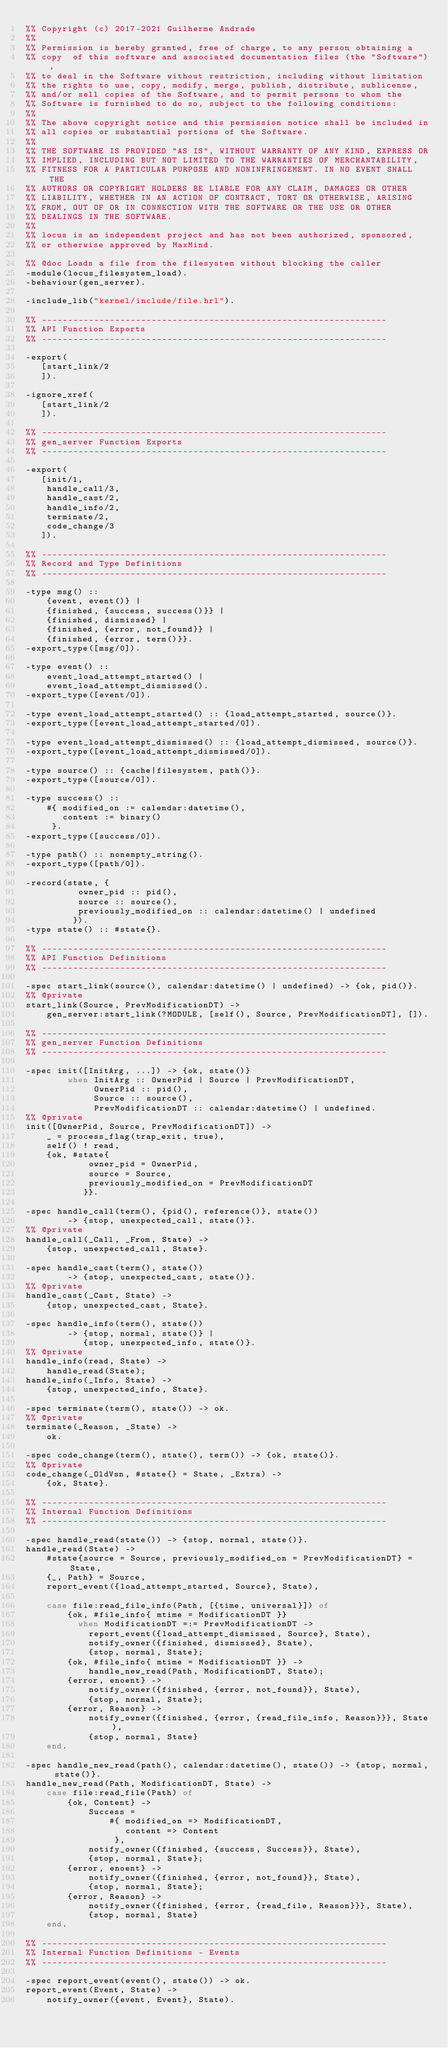Convert code to text. <code><loc_0><loc_0><loc_500><loc_500><_Erlang_>%% Copyright (c) 2017-2021 Guilherme Andrade
%%
%% Permission is hereby granted, free of charge, to any person obtaining a
%% copy  of this software and associated documentation files (the "Software"),
%% to deal in the Software without restriction, including without limitation
%% the rights to use, copy, modify, merge, publish, distribute, sublicense,
%% and/or sell copies of the Software, and to permit persons to whom the
%% Software is furnished to do so, subject to the following conditions:
%%
%% The above copyright notice and this permission notice shall be included in
%% all copies or substantial portions of the Software.
%%
%% THE SOFTWARE IS PROVIDED "AS IS", WITHOUT WARRANTY OF ANY KIND, EXPRESS OR
%% IMPLIED, INCLUDING BUT NOT LIMITED TO THE WARRANTIES OF MERCHANTABILITY,
%% FITNESS FOR A PARTICULAR PURPOSE AND NONINFRINGEMENT. IN NO EVENT SHALL THE
%% AUTHORS OR COPYRIGHT HOLDERS BE LIABLE FOR ANY CLAIM, DAMAGES OR OTHER
%% LIABILITY, WHETHER IN AN ACTION OF CONTRACT, TORT OR OTHERWISE, ARISING
%% FROM, OUT OF OR IN CONNECTION WITH THE SOFTWARE OR THE USE OR OTHER
%% DEALINGS IN THE SOFTWARE.
%%
%% locus is an independent project and has not been authorized, sponsored,
%% or otherwise approved by MaxMind.

%% @doc Loads a file from the filesystem without blocking the caller
-module(locus_filesystem_load).
-behaviour(gen_server).

-include_lib("kernel/include/file.hrl").

%% ------------------------------------------------------------------
%% API Function Exports
%% ------------------------------------------------------------------

-export(
   [start_link/2
   ]).

-ignore_xref(
   [start_link/2
   ]).

%% ------------------------------------------------------------------
%% gen_server Function Exports
%% ------------------------------------------------------------------

-export(
   [init/1,
    handle_call/3,
    handle_cast/2,
    handle_info/2,
    terminate/2,
    code_change/3
   ]).

%% ------------------------------------------------------------------
%% Record and Type Definitions
%% ------------------------------------------------------------------

-type msg() ::
    {event, event()} |
    {finished, {success, success()}} |
    {finished, dismissed} |
    {finished, {error, not_found}} |
    {finished, {error, term()}}.
-export_type([msg/0]).

-type event() ::
    event_load_attempt_started() |
    event_load_attempt_dismissed().
-export_type([event/0]).

-type event_load_attempt_started() :: {load_attempt_started, source()}.
-export_type([event_load_attempt_started/0]).

-type event_load_attempt_dismissed() :: {load_attempt_dismissed, source()}.
-export_type([event_load_attempt_dismissed/0]).

-type source() :: {cache|filesystem, path()}.
-export_type([source/0]).

-type success() ::
    #{ modified_on := calendar:datetime(),
       content := binary()
     }.
-export_type([success/0]).

-type path() :: nonempty_string().
-export_type([path/0]).

-record(state, {
          owner_pid :: pid(),
          source :: source(),
          previously_modified_on :: calendar:datetime() | undefined
         }).
-type state() :: #state{}.

%% ------------------------------------------------------------------
%% API Function Definitions
%% ------------------------------------------------------------------

-spec start_link(source(), calendar:datetime() | undefined) -> {ok, pid()}.
%% @private
start_link(Source, PrevModificationDT) ->
    gen_server:start_link(?MODULE, [self(), Source, PrevModificationDT], []).

%% ------------------------------------------------------------------
%% gen_server Function Definitions
%% ------------------------------------------------------------------

-spec init([InitArg, ...]) -> {ok, state()}
        when InitArg :: OwnerPid | Source | PrevModificationDT,
             OwnerPid :: pid(),
             Source :: source(),
             PrevModificationDT :: calendar:datetime() | undefined.
%% @private
init([OwnerPid, Source, PrevModificationDT]) ->
    _ = process_flag(trap_exit, true),
    self() ! read,
    {ok, #state{
            owner_pid = OwnerPid,
            source = Source,
            previously_modified_on = PrevModificationDT
           }}.

-spec handle_call(term(), {pid(), reference()}, state())
        -> {stop, unexpected_call, state()}.
%% @private
handle_call(_Call, _From, State) ->
    {stop, unexpected_call, State}.

-spec handle_cast(term(), state())
        -> {stop, unexpected_cast, state()}.
%% @private
handle_cast(_Cast, State) ->
    {stop, unexpected_cast, State}.

-spec handle_info(term(), state())
        -> {stop, normal, state()} |
           {stop, unexpected_info, state()}.
%% @private
handle_info(read, State) ->
    handle_read(State);
handle_info(_Info, State) ->
    {stop, unexpected_info, State}.

-spec terminate(term(), state()) -> ok.
%% @private
terminate(_Reason, _State) ->
    ok.

-spec code_change(term(), state(), term()) -> {ok, state()}.
%% @private
code_change(_OldVsn, #state{} = State, _Extra) ->
    {ok, State}.

%% ------------------------------------------------------------------
%% Internal Function Definitions
%% ------------------------------------------------------------------

-spec handle_read(state()) -> {stop, normal, state()}.
handle_read(State) ->
    #state{source = Source, previously_modified_on = PrevModificationDT} = State,
    {_, Path} = Source,
    report_event({load_attempt_started, Source}, State),

    case file:read_file_info(Path, [{time, universal}]) of
        {ok, #file_info{ mtime = ModificationDT }}
          when ModificationDT =:= PrevModificationDT ->
            report_event({load_attempt_dismissed, Source}, State),
            notify_owner({finished, dismissed}, State),
            {stop, normal, State};
        {ok, #file_info{ mtime = ModificationDT }} ->
            handle_new_read(Path, ModificationDT, State);
        {error, enoent} ->
            notify_owner({finished, {error, not_found}}, State),
            {stop, normal, State};
        {error, Reason} ->
            notify_owner({finished, {error, {read_file_info, Reason}}}, State),
            {stop, normal, State}
    end.

-spec handle_new_read(path(), calendar:datetime(), state()) -> {stop, normal, state()}.
handle_new_read(Path, ModificationDT, State) ->
    case file:read_file(Path) of
        {ok, Content} ->
            Success =
                #{ modified_on => ModificationDT,
                   content => Content
                 },
            notify_owner({finished, {success, Success}}, State),
            {stop, normal, State};
        {error, enoent} ->
            notify_owner({finished, {error, not_found}}, State),
            {stop, normal, State};
        {error, Reason} ->
            notify_owner({finished, {error, {read_file, Reason}}}, State),
            {stop, normal, State}
    end.

%% ------------------------------------------------------------------
%% Internal Function Definitions - Events
%% ------------------------------------------------------------------

-spec report_event(event(), state()) -> ok.
report_event(Event, State) ->
    notify_owner({event, Event}, State).
</code> 